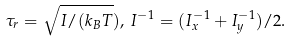Convert formula to latex. <formula><loc_0><loc_0><loc_500><loc_500>\tau _ { r } = \sqrt { I / ( k _ { B } T } ) , \, I ^ { - 1 } = ( I _ { x } ^ { - 1 } + I _ { y } ^ { - 1 } ) / 2 .</formula> 